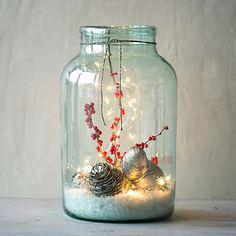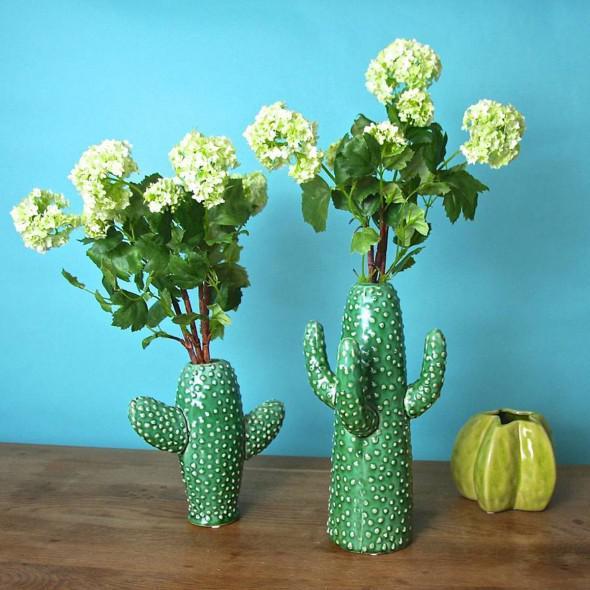The first image is the image on the left, the second image is the image on the right. Analyze the images presented: Is the assertion "At least one image features vases that look like cacti." valid? Answer yes or no. Yes. The first image is the image on the left, the second image is the image on the right. Examine the images to the left and right. Is the description "At least one photo features cactus-shaped vases." accurate? Answer yes or no. Yes. 